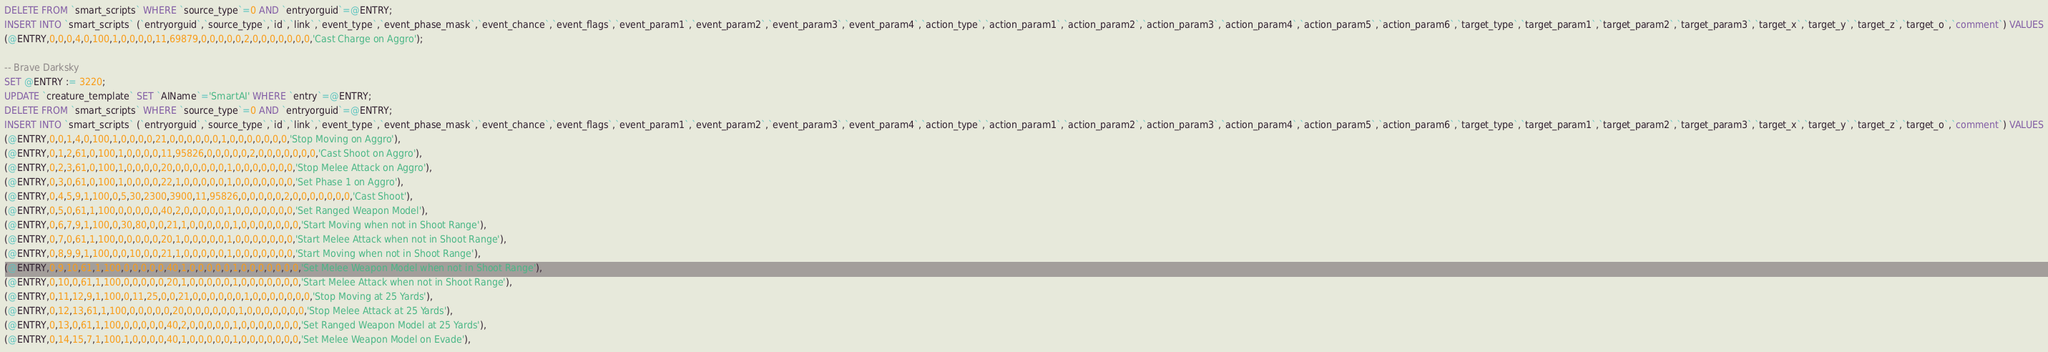<code> <loc_0><loc_0><loc_500><loc_500><_SQL_>DELETE FROM `smart_scripts` WHERE `source_type`=0 AND `entryorguid`=@ENTRY;
INSERT INTO `smart_scripts` (`entryorguid`,`source_type`,`id`,`link`,`event_type`,`event_phase_mask`,`event_chance`,`event_flags`,`event_param1`,`event_param2`,`event_param3`,`event_param4`,`action_type`,`action_param1`,`action_param2`,`action_param3`,`action_param4`,`action_param5`,`action_param6`,`target_type`,`target_param1`,`target_param2`,`target_param3`,`target_x`,`target_y`,`target_z`,`target_o`,`comment`) VALUES
(@ENTRY,0,0,0,4,0,100,1,0,0,0,0,11,69879,0,0,0,0,0,2,0,0,0,0,0,0,0,'Cast Charge on Aggro');

-- Brave Darksky
SET @ENTRY := 3220;
UPDATE `creature_template` SET `AIName`='SmartAI' WHERE `entry`=@ENTRY;
DELETE FROM `smart_scripts` WHERE `source_type`=0 AND `entryorguid`=@ENTRY;
INSERT INTO `smart_scripts` (`entryorguid`,`source_type`,`id`,`link`,`event_type`,`event_phase_mask`,`event_chance`,`event_flags`,`event_param1`,`event_param2`,`event_param3`,`event_param4`,`action_type`,`action_param1`,`action_param2`,`action_param3`,`action_param4`,`action_param5`,`action_param6`,`target_type`,`target_param1`,`target_param2`,`target_param3`,`target_x`,`target_y`,`target_z`,`target_o`,`comment`) VALUES
(@ENTRY,0,0,1,4,0,100,1,0,0,0,0,21,0,0,0,0,0,0,1,0,0,0,0,0,0,0,'Stop Moving on Aggro'),
(@ENTRY,0,1,2,61,0,100,1,0,0,0,0,11,95826,0,0,0,0,0,2,0,0,0,0,0,0,0,'Cast Shoot on Aggro'),
(@ENTRY,0,2,3,61,0,100,1,0,0,0,0,20,0,0,0,0,0,0,1,0,0,0,0,0,0,0,'Stop Melee Attack on Aggro'),
(@ENTRY,0,3,0,61,0,100,1,0,0,0,0,22,1,0,0,0,0,0,1,0,0,0,0,0,0,0,'Set Phase 1 on Aggro'),
(@ENTRY,0,4,5,9,1,100,0,5,30,2300,3900,11,95826,0,0,0,0,0,2,0,0,0,0,0,0,0,'Cast Shoot'),
(@ENTRY,0,5,0,61,1,100,0,0,0,0,0,40,2,0,0,0,0,0,1,0,0,0,0,0,0,0,'Set Ranged Weapon Model'),
(@ENTRY,0,6,7,9,1,100,0,30,80,0,0,21,1,0,0,0,0,0,1,0,0,0,0,0,0,0,'Start Moving when not in Shoot Range'),
(@ENTRY,0,7,0,61,1,100,0,0,0,0,0,20,1,0,0,0,0,0,1,0,0,0,0,0,0,0,'Start Melee Attack when not in Shoot Range'),
(@ENTRY,0,8,9,9,1,100,0,0,10,0,0,21,1,0,0,0,0,0,1,0,0,0,0,0,0,0,'Start Moving when not in Shoot Range'),
(@ENTRY,0,9,10,61,1,100,0,0,0,0,0,40,1,0,0,0,0,0,1,0,0,0,0,0,0,0,'Set Melee Weapon Model when not in Shoot Range'),
(@ENTRY,0,10,0,61,1,100,0,0,0,0,0,20,1,0,0,0,0,0,1,0,0,0,0,0,0,0,'Start Melee Attack when not in Shoot Range'),
(@ENTRY,0,11,12,9,1,100,0,11,25,0,0,21,0,0,0,0,0,0,1,0,0,0,0,0,0,0,'Stop Moving at 25 Yards'),
(@ENTRY,0,12,13,61,1,100,0,0,0,0,0,20,0,0,0,0,0,0,1,0,0,0,0,0,0,0,'Stop Melee Attack at 25 Yards'),
(@ENTRY,0,13,0,61,1,100,0,0,0,0,0,40,2,0,0,0,0,0,1,0,0,0,0,0,0,0,'Set Ranged Weapon Model at 25 Yards'),
(@ENTRY,0,14,15,7,1,100,1,0,0,0,0,40,1,0,0,0,0,0,1,0,0,0,0,0,0,0,'Set Melee Weapon Model on Evade'),</code> 